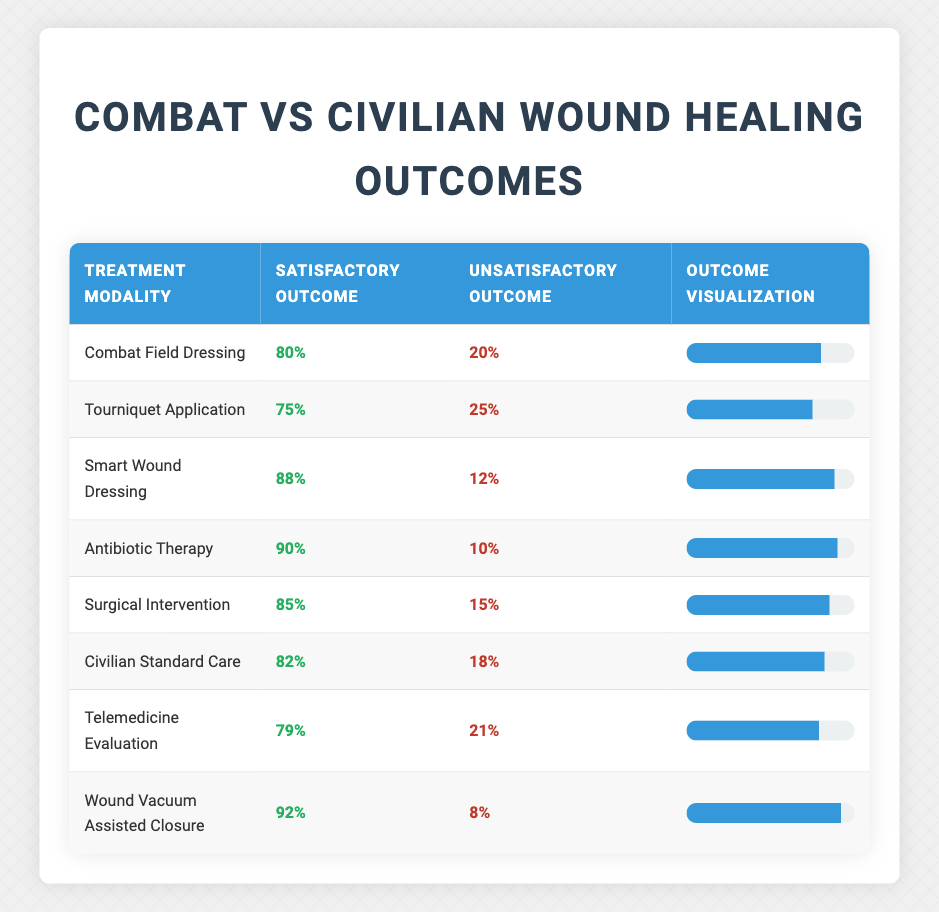What is the satisfactory outcome percentage for Smart Wound Dressing? The table shows that for Smart Wound Dressing, the satisfactory outcome is listed as 88%.
Answer: 88% Which treatment modality has the lowest satisfactory outcome? By comparing the satisfactory outcomes across all modalities, Tourniquet Application has the lowest at 75%.
Answer: Tourniquet Application What is the difference in satisfactory outcome percentage between Wound Vacuum Assisted Closure and Civilian Standard Care? Wound Vacuum Assisted Closure has a satisfactory outcome of 92%, while Civilian Standard Care has 82%. The difference is 92 - 82 = 10%.
Answer: 10% Is the satisfactory outcome for Antibiotic Therapy more than 85%? The table indicates that the satisfactory outcome for Antibiotic Therapy is 90%, which is indeed more than 85%.
Answer: Yes What is the average satisfactory outcome percentage for all treatment modalities listed? To find the average, add all satisfactory outcomes (80 + 75 + 88 + 90 + 85 + 82 + 79 + 92) = 691, then divide by the number of modalities (8). 691 / 8 = 86.375.
Answer: 86.375 